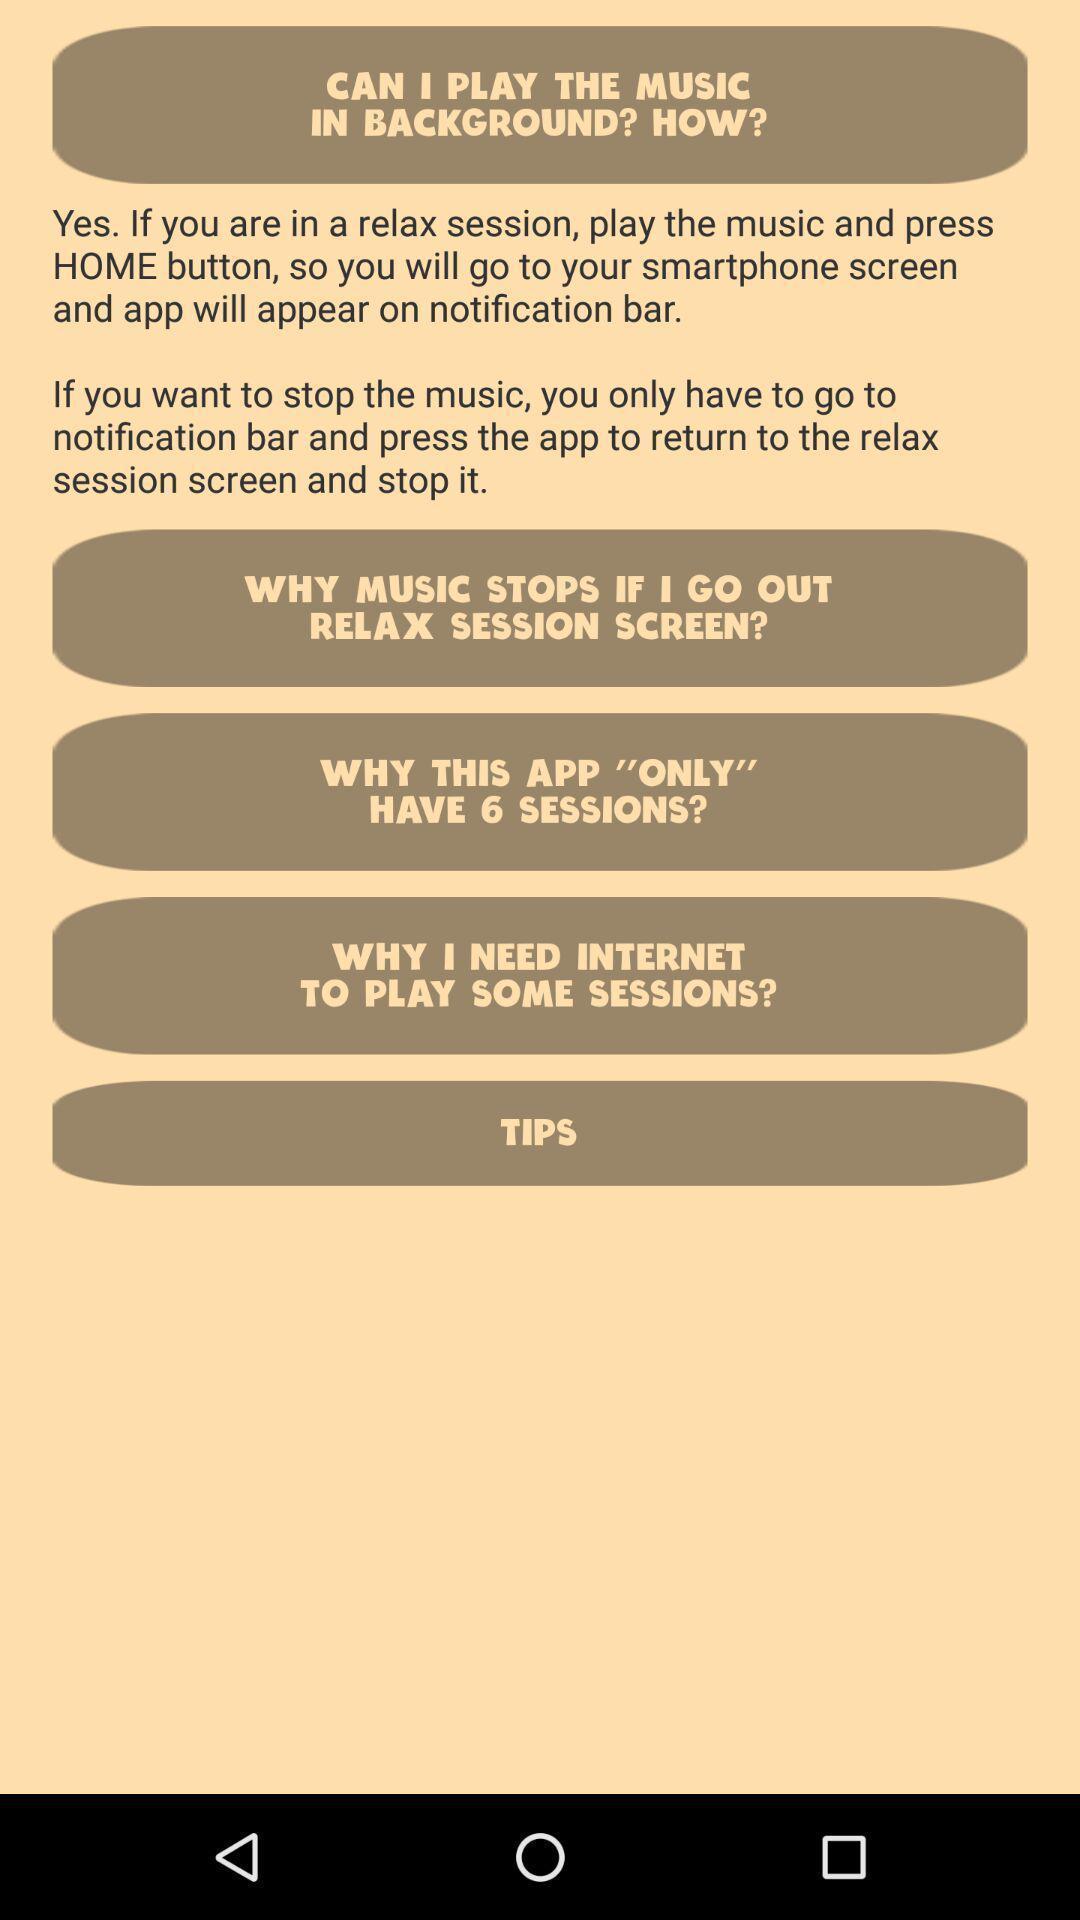What can you discern from this picture? Screen displaying list of questions about an app. 